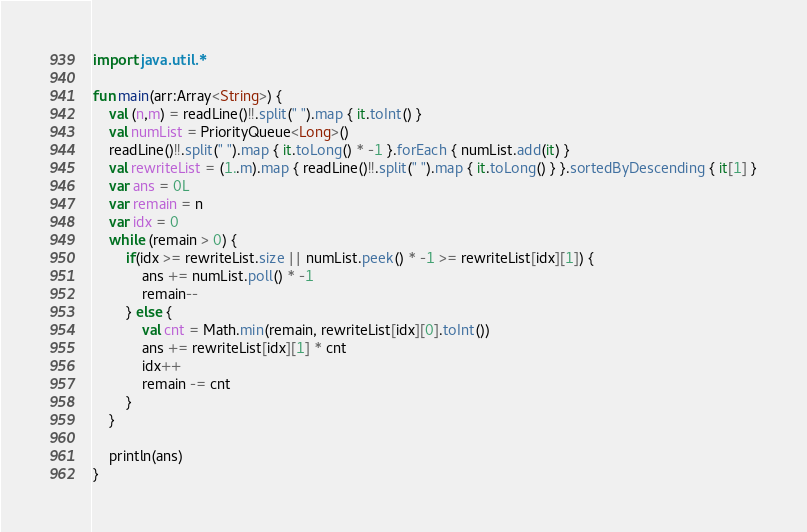<code> <loc_0><loc_0><loc_500><loc_500><_Kotlin_>import java.util.*

fun main(arr:Array<String>) {
    val (n,m) = readLine()!!.split(" ").map { it.toInt() }
    val numList = PriorityQueue<Long>()
    readLine()!!.split(" ").map { it.toLong() * -1 }.forEach { numList.add(it) }
    val rewriteList = (1..m).map { readLine()!!.split(" ").map { it.toLong() } }.sortedByDescending { it[1] }
    var ans = 0L
    var remain = n
    var idx = 0
    while (remain > 0) {
        if(idx >= rewriteList.size || numList.peek() * -1 >= rewriteList[idx][1]) {
            ans += numList.poll() * -1
            remain--
        } else {
            val cnt = Math.min(remain, rewriteList[idx][0].toInt())
            ans += rewriteList[idx][1] * cnt
            idx++
            remain -= cnt
        }
    }

    println(ans)
}

</code> 